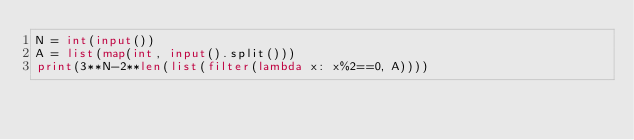Convert code to text. <code><loc_0><loc_0><loc_500><loc_500><_Python_>N = int(input())
A = list(map(int, input().split()))
print(3**N-2**len(list(filter(lambda x: x%2==0, A))))</code> 